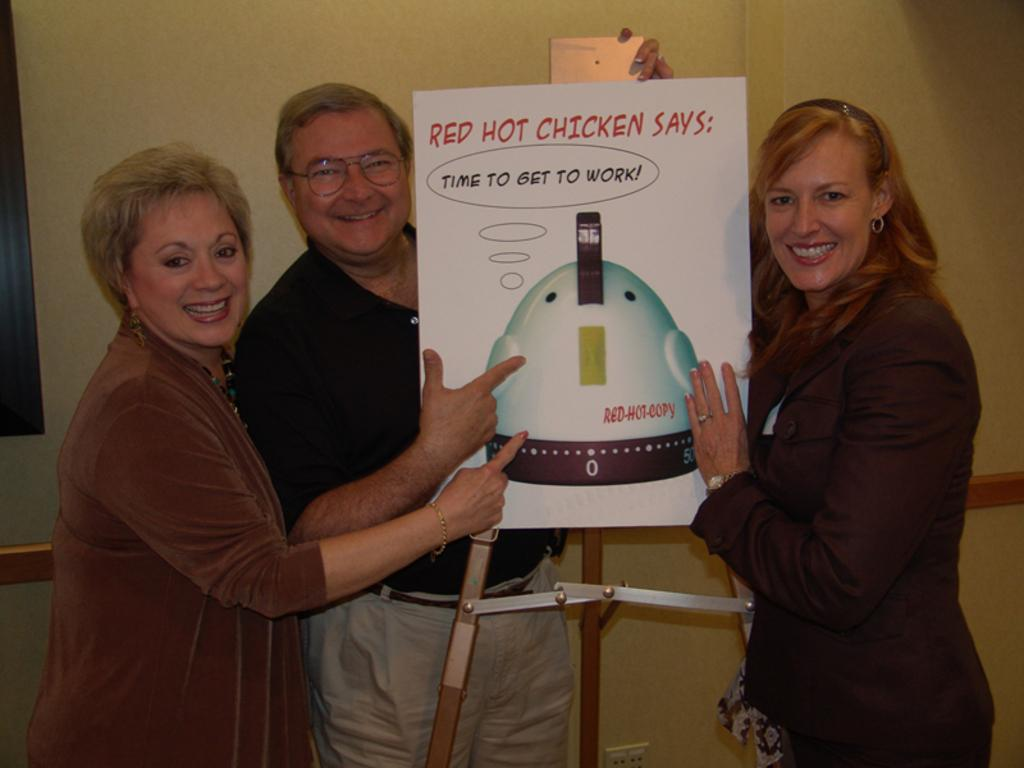What is happening in the image? There are people standing in the image. What object can be seen on a stand in the image? There is a board on a stand in the image. What can be seen in the background of the image? There is a wall visible in the background of the image. How many cubs are playing with the people in the image? There are no cubs present in the image; it only features people and a board on a stand. 